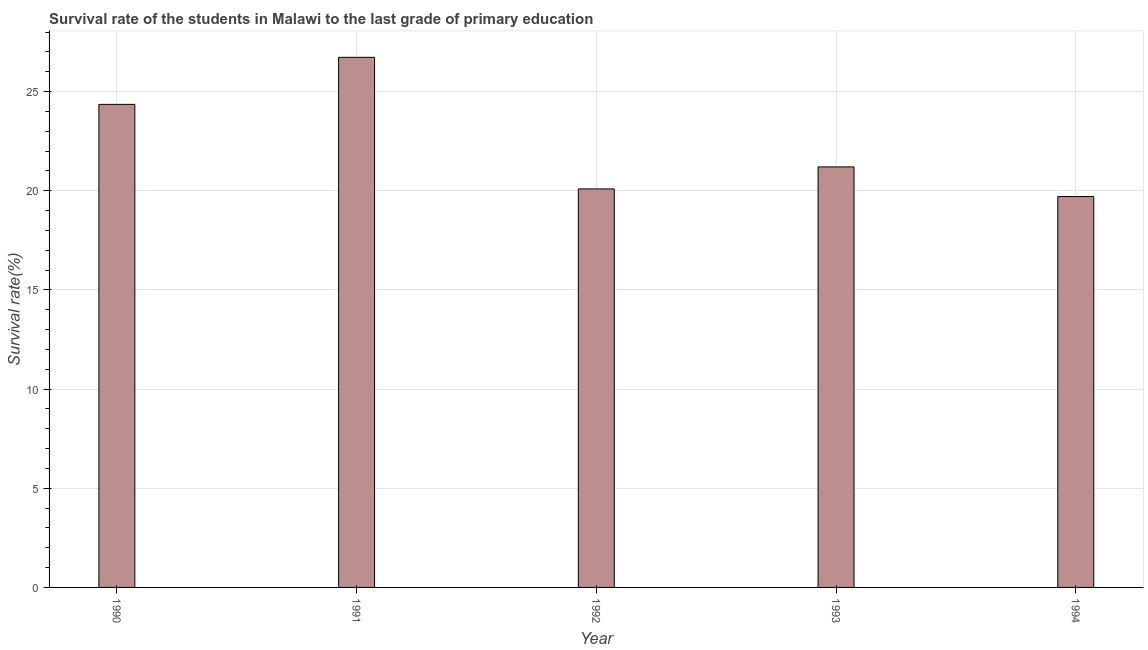Does the graph contain any zero values?
Ensure brevity in your answer.  No. Does the graph contain grids?
Offer a very short reply. Yes. What is the title of the graph?
Keep it short and to the point. Survival rate of the students in Malawi to the last grade of primary education. What is the label or title of the X-axis?
Your answer should be compact. Year. What is the label or title of the Y-axis?
Your answer should be compact. Survival rate(%). What is the survival rate in primary education in 1992?
Ensure brevity in your answer.  20.09. Across all years, what is the maximum survival rate in primary education?
Offer a very short reply. 26.73. Across all years, what is the minimum survival rate in primary education?
Ensure brevity in your answer.  19.71. In which year was the survival rate in primary education maximum?
Offer a terse response. 1991. In which year was the survival rate in primary education minimum?
Make the answer very short. 1994. What is the sum of the survival rate in primary education?
Give a very brief answer. 112.09. What is the difference between the survival rate in primary education in 1990 and 1993?
Your answer should be compact. 3.15. What is the average survival rate in primary education per year?
Your response must be concise. 22.42. What is the median survival rate in primary education?
Offer a terse response. 21.2. In how many years, is the survival rate in primary education greater than 6 %?
Your answer should be compact. 5. Do a majority of the years between 1993 and 1992 (inclusive) have survival rate in primary education greater than 3 %?
Provide a succinct answer. No. What is the ratio of the survival rate in primary education in 1990 to that in 1994?
Your response must be concise. 1.24. Is the survival rate in primary education in 1992 less than that in 1994?
Give a very brief answer. No. Is the difference between the survival rate in primary education in 1990 and 1992 greater than the difference between any two years?
Make the answer very short. No. What is the difference between the highest and the second highest survival rate in primary education?
Provide a succinct answer. 2.37. What is the difference between the highest and the lowest survival rate in primary education?
Ensure brevity in your answer.  7.02. How many years are there in the graph?
Your response must be concise. 5. Are the values on the major ticks of Y-axis written in scientific E-notation?
Provide a short and direct response. No. What is the Survival rate(%) of 1990?
Your answer should be compact. 24.36. What is the Survival rate(%) of 1991?
Your response must be concise. 26.73. What is the Survival rate(%) of 1992?
Your answer should be compact. 20.09. What is the Survival rate(%) in 1993?
Offer a terse response. 21.2. What is the Survival rate(%) in 1994?
Your answer should be compact. 19.71. What is the difference between the Survival rate(%) in 1990 and 1991?
Ensure brevity in your answer.  -2.37. What is the difference between the Survival rate(%) in 1990 and 1992?
Provide a succinct answer. 4.26. What is the difference between the Survival rate(%) in 1990 and 1993?
Provide a short and direct response. 3.15. What is the difference between the Survival rate(%) in 1990 and 1994?
Your answer should be compact. 4.65. What is the difference between the Survival rate(%) in 1991 and 1992?
Your response must be concise. 6.63. What is the difference between the Survival rate(%) in 1991 and 1993?
Your response must be concise. 5.53. What is the difference between the Survival rate(%) in 1991 and 1994?
Your answer should be compact. 7.02. What is the difference between the Survival rate(%) in 1992 and 1993?
Give a very brief answer. -1.11. What is the difference between the Survival rate(%) in 1992 and 1994?
Give a very brief answer. 0.39. What is the difference between the Survival rate(%) in 1993 and 1994?
Offer a very short reply. 1.5. What is the ratio of the Survival rate(%) in 1990 to that in 1991?
Your answer should be very brief. 0.91. What is the ratio of the Survival rate(%) in 1990 to that in 1992?
Offer a terse response. 1.21. What is the ratio of the Survival rate(%) in 1990 to that in 1993?
Your response must be concise. 1.15. What is the ratio of the Survival rate(%) in 1990 to that in 1994?
Make the answer very short. 1.24. What is the ratio of the Survival rate(%) in 1991 to that in 1992?
Offer a very short reply. 1.33. What is the ratio of the Survival rate(%) in 1991 to that in 1993?
Provide a short and direct response. 1.26. What is the ratio of the Survival rate(%) in 1991 to that in 1994?
Make the answer very short. 1.36. What is the ratio of the Survival rate(%) in 1992 to that in 1993?
Make the answer very short. 0.95. What is the ratio of the Survival rate(%) in 1992 to that in 1994?
Provide a succinct answer. 1.02. What is the ratio of the Survival rate(%) in 1993 to that in 1994?
Your answer should be very brief. 1.08. 